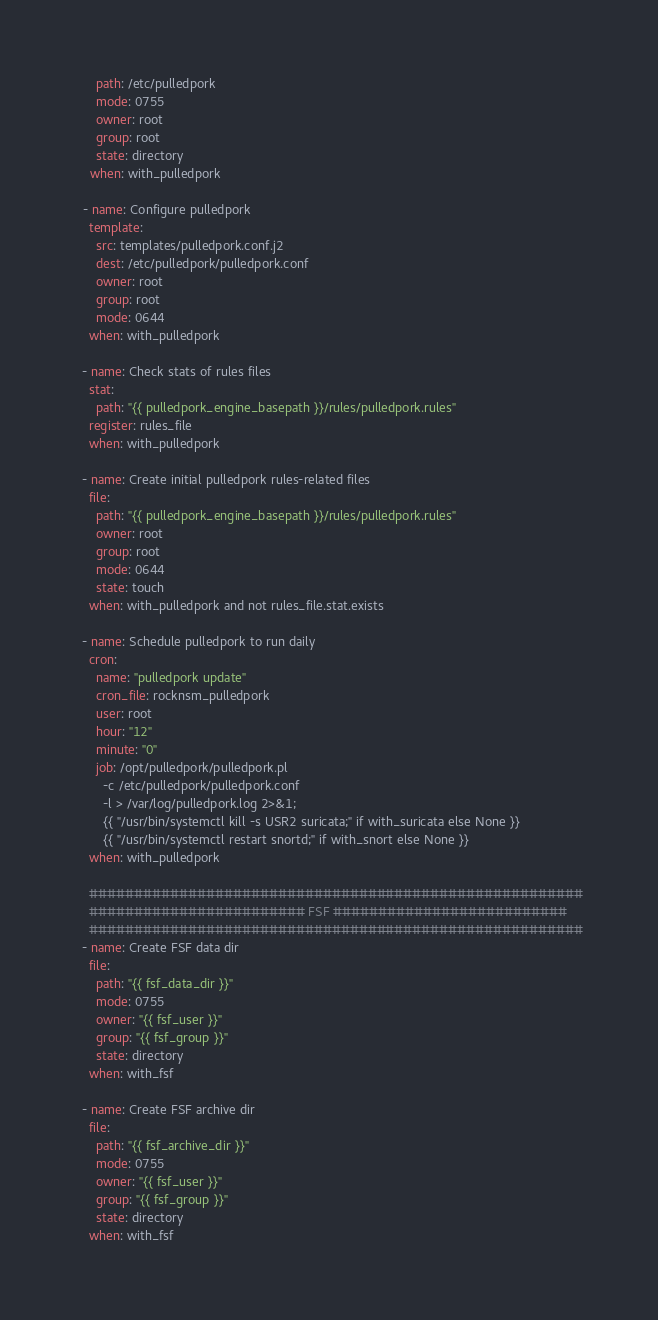Convert code to text. <code><loc_0><loc_0><loc_500><loc_500><_YAML_>      path: /etc/pulledpork
      mode: 0755
      owner: root
      group: root
      state: directory
    when: with_pulledpork

  - name: Configure pulledpork
    template:
      src: templates/pulledpork.conf.j2
      dest: /etc/pulledpork/pulledpork.conf
      owner: root
      group: root
      mode: 0644
    when: with_pulledpork

  - name: Check stats of rules files
    stat:
      path: "{{ pulledpork_engine_basepath }}/rules/pulledpork.rules"
    register: rules_file
    when: with_pulledpork

  - name: Create initial pulledpork rules-related files
    file:
      path: "{{ pulledpork_engine_basepath }}/rules/pulledpork.rules"
      owner: root
      group: root
      mode: 0644
      state: touch
    when: with_pulledpork and not rules_file.stat.exists

  - name: Schedule pulledpork to run daily
    cron:
      name: "pulledpork update"
      cron_file: rocknsm_pulledpork
      user: root
      hour: "12"
      minute: "0"
      job: /opt/pulledpork/pulledpork.pl
        -c /etc/pulledpork/pulledpork.conf
        -l > /var/log/pulledpork.log 2>&1;
        {{ "/usr/bin/systemctl kill -s USR2 suricata;" if with_suricata else None }}
        {{ "/usr/bin/systemctl restart snortd;" if with_snort else None }}
    when: with_pulledpork

    #######################################################
    ######################## FSF ##########################
    #######################################################
  - name: Create FSF data dir
    file:
      path: "{{ fsf_data_dir }}"
      mode: 0755
      owner: "{{ fsf_user }}"
      group: "{{ fsf_group }}"
      state: directory
    when: with_fsf

  - name: Create FSF archive dir
    file:
      path: "{{ fsf_archive_dir }}"
      mode: 0755
      owner: "{{ fsf_user }}"
      group: "{{ fsf_group }}"
      state: directory
    when: with_fsf
</code> 